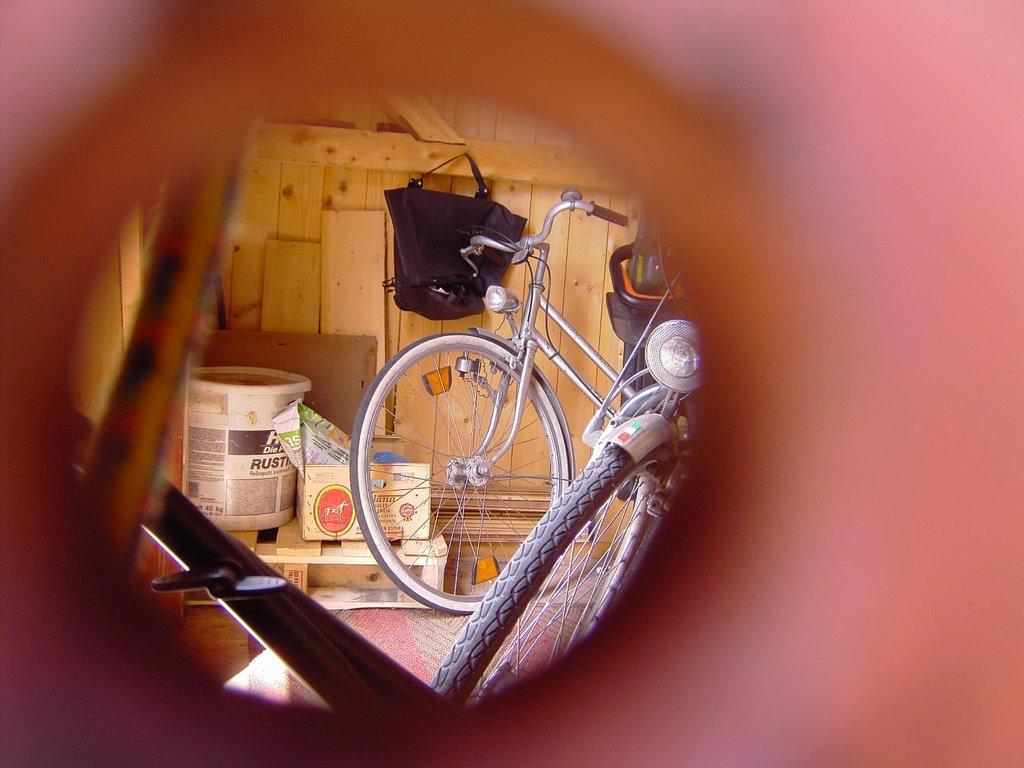What type of vehicle is in the image? There is a bicycle in the image. What other objects can be seen in the image? There is a box, a container, a bag, and a wooden object in the image. What type of boot is visible on the bicycle in the image? There is no boot present on the bicycle in the image. What is the bicycle learning to do in the image? The bicycle is not capable of learning, as it is an inanimate object. 